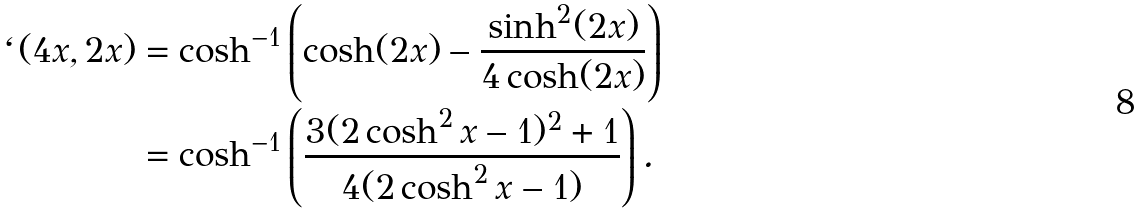<formula> <loc_0><loc_0><loc_500><loc_500>\ell ( 4 x , 2 x ) & = \cosh ^ { - 1 } \left ( \cosh ( 2 x ) - \frac { \sinh ^ { 2 } ( 2 x ) } { 4 \cosh ( 2 x ) } \right ) \\ & = \cosh ^ { - 1 } \left ( \frac { 3 ( 2 \cosh ^ { 2 } x - 1 ) ^ { 2 } + 1 } { 4 ( 2 \cosh ^ { 2 } x - 1 ) } \right ) .</formula> 